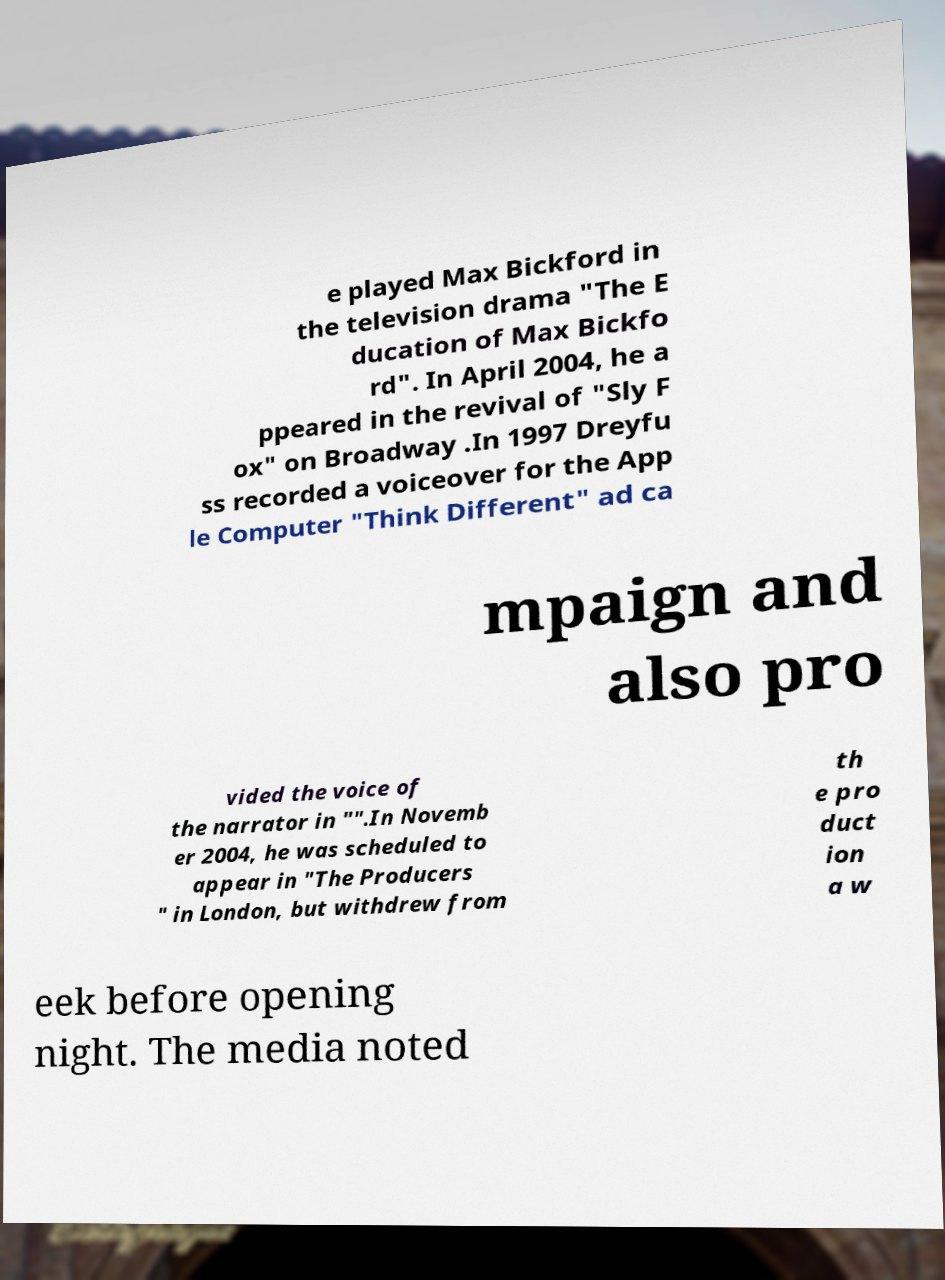There's text embedded in this image that I need extracted. Can you transcribe it verbatim? e played Max Bickford in the television drama "The E ducation of Max Bickfo rd". In April 2004, he a ppeared in the revival of "Sly F ox" on Broadway .In 1997 Dreyfu ss recorded a voiceover for the App le Computer "Think Different" ad ca mpaign and also pro vided the voice of the narrator in "".In Novemb er 2004, he was scheduled to appear in "The Producers " in London, but withdrew from th e pro duct ion a w eek before opening night. The media noted 